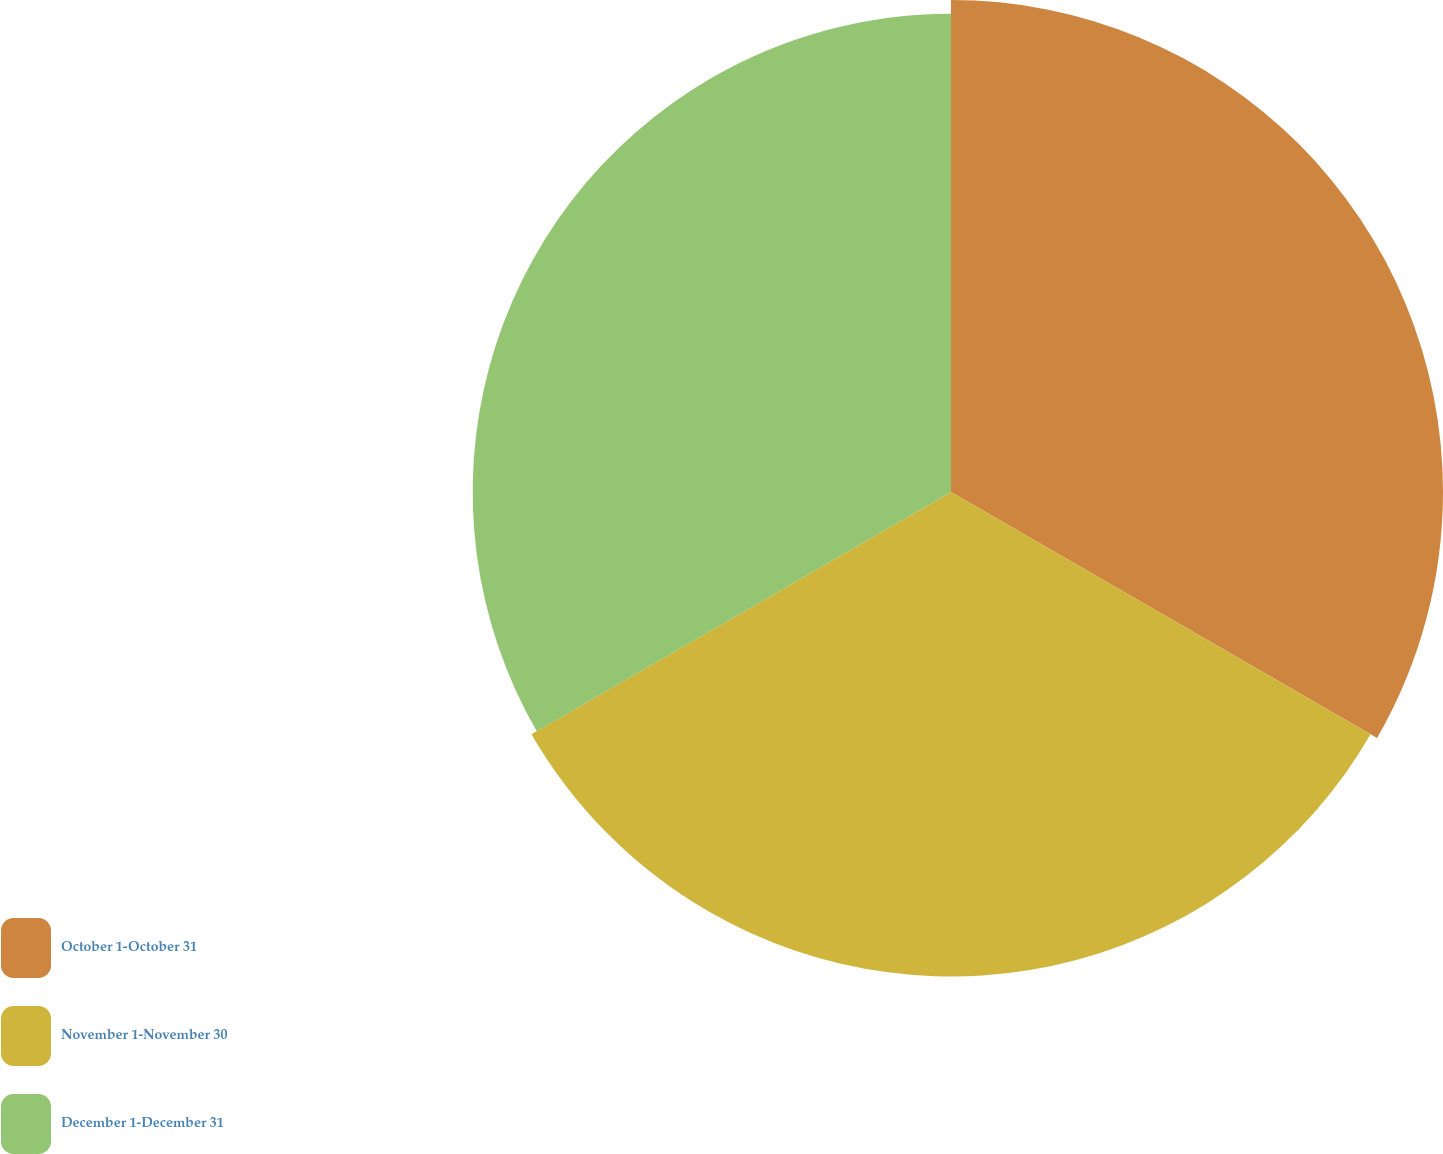Convert chart to OTSL. <chart><loc_0><loc_0><loc_500><loc_500><pie_chart><fcel>October 1-October 31<fcel>November 1-November 30<fcel>December 1-December 31<nl><fcel>33.82%<fcel>33.3%<fcel>32.88%<nl></chart> 